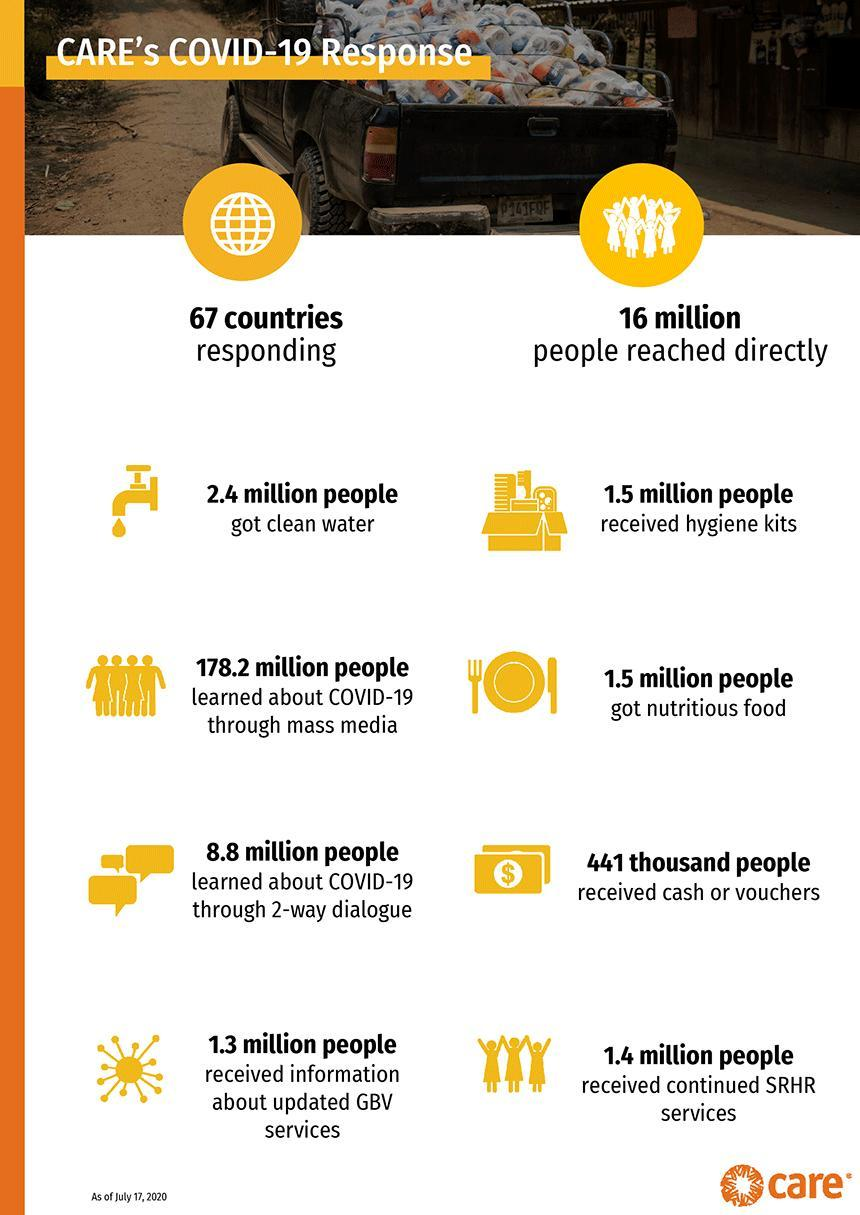How many people around the world learned about COVID-19 through 2-way dialogue with the help of CARE as of July 17, 2020?
Answer the question with a short phrase. 8.8 million How many people around the world learned about COVID-19 through mass media with the help of CARE as of July 17, 2020? 178.2 million How many people worldwide received continued SRHR services as a part of Care's Covid-19 mission as of July 17, 2020? 1.4 million people How many people worldwide received hygiene kits as a part of Care's Covid-19 mission as of July 17, 2020? 1.5 million people How many people around the world received cash or vouchers as a part of Care's Covid-19 mission as of July 17, 2020? 441 thousand people 